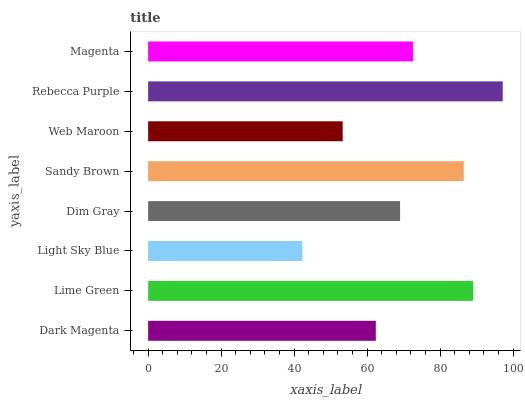Is Light Sky Blue the minimum?
Answer yes or no. Yes. Is Rebecca Purple the maximum?
Answer yes or no. Yes. Is Lime Green the minimum?
Answer yes or no. No. Is Lime Green the maximum?
Answer yes or no. No. Is Lime Green greater than Dark Magenta?
Answer yes or no. Yes. Is Dark Magenta less than Lime Green?
Answer yes or no. Yes. Is Dark Magenta greater than Lime Green?
Answer yes or no. No. Is Lime Green less than Dark Magenta?
Answer yes or no. No. Is Magenta the high median?
Answer yes or no. Yes. Is Dim Gray the low median?
Answer yes or no. Yes. Is Light Sky Blue the high median?
Answer yes or no. No. Is Rebecca Purple the low median?
Answer yes or no. No. 